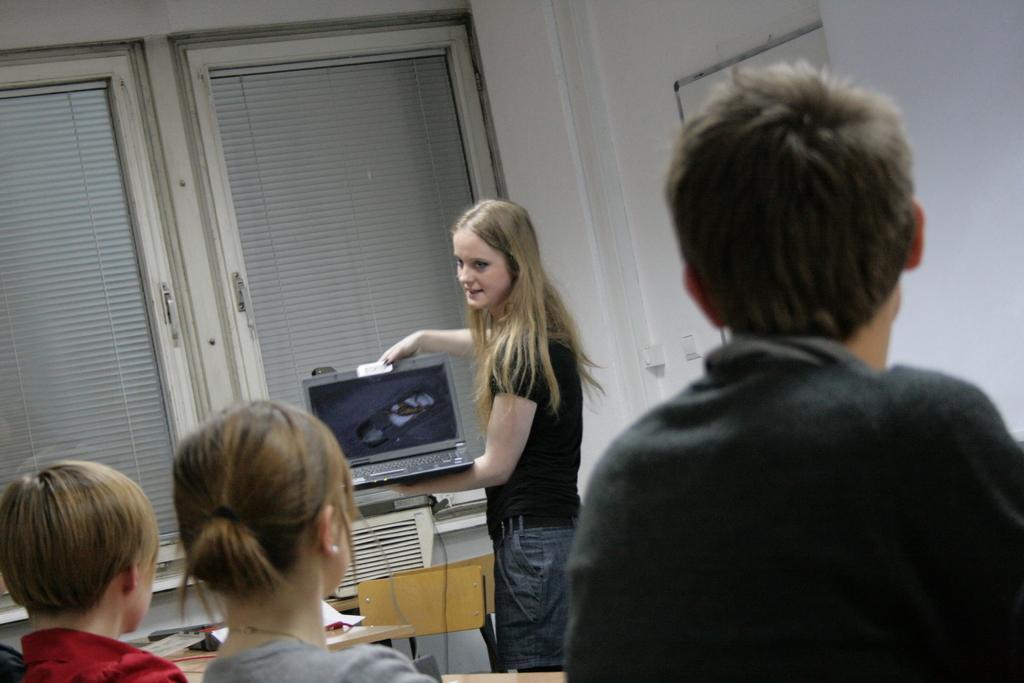Describe this image in one or two sentences. This image is taken indoors. In the background there is a wall with windows. At the bottom of the image a boy and two kids are sitting on the chairs and there is a table with a few things on it. In the middle of the image a girl is standing on the floor and she is holding a laptop in her hands. 